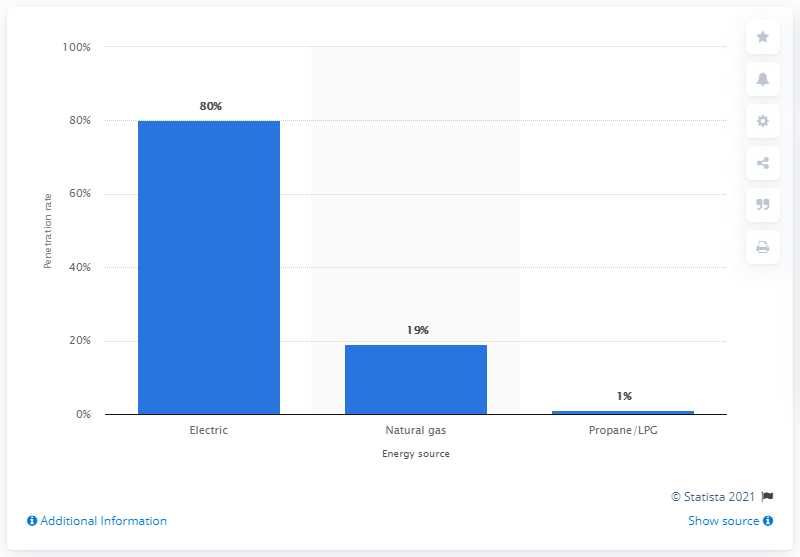Point out several critical features in this image. According to data from 2009, the household penetration rate of electric clothes dryers in the United States was approximately 90%. 